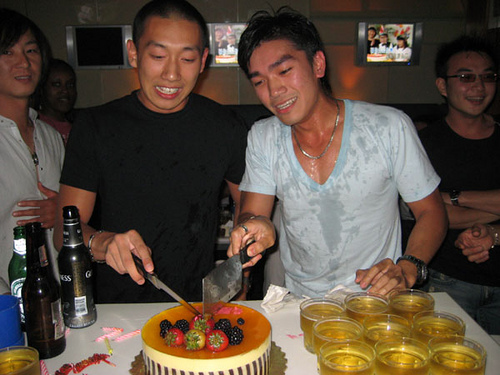What is in the cups? The cups seem to contain a beverage resembling beer, given their color and the party setting. 